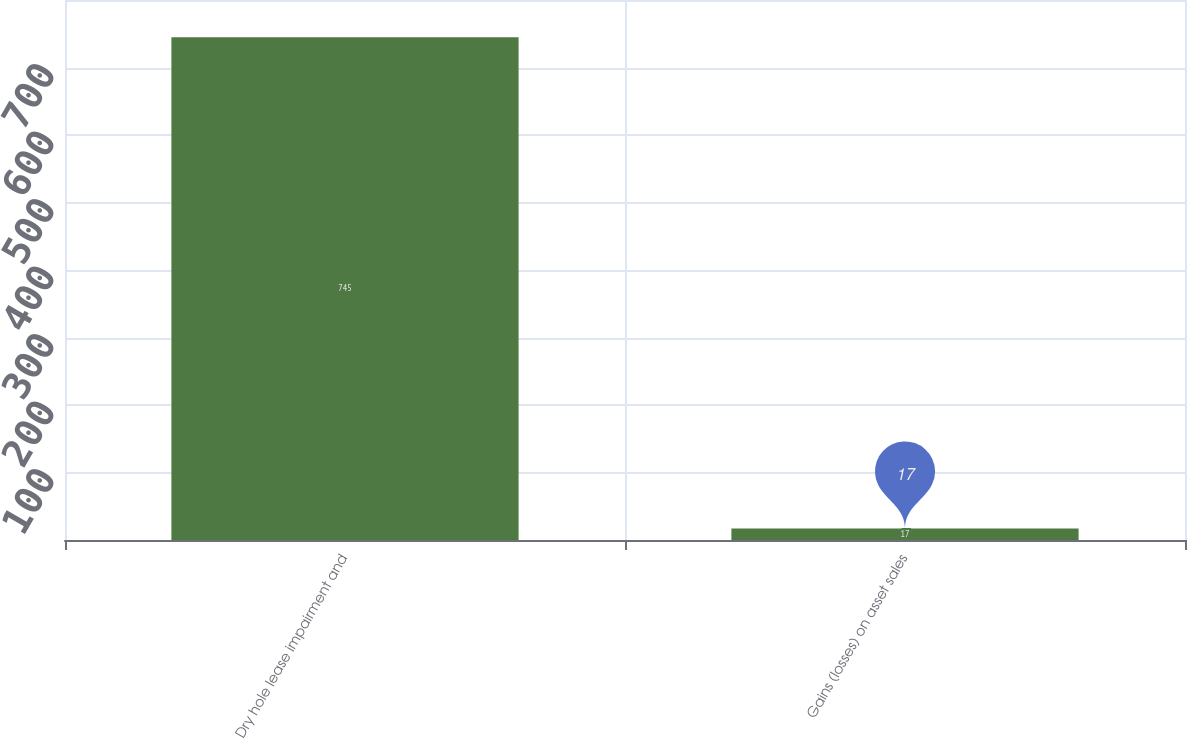Convert chart. <chart><loc_0><loc_0><loc_500><loc_500><bar_chart><fcel>Dry hole lease impairment and<fcel>Gains (losses) on asset sales<nl><fcel>745<fcel>17<nl></chart> 